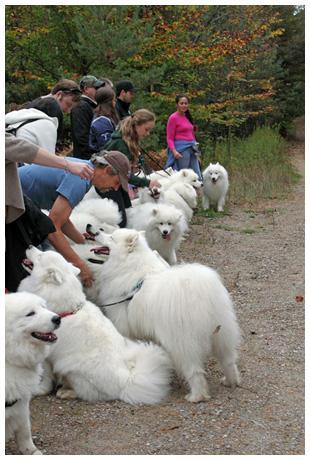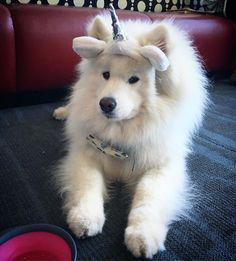The first image is the image on the left, the second image is the image on the right. For the images displayed, is the sentence "One image has a dog wearing more than just a collar or leash." factually correct? Answer yes or no. Yes. The first image is the image on the left, the second image is the image on the right. For the images shown, is this caption "In at least one image you can see at least one human wearing jeans feeding no less than 6 white dogs." true? Answer yes or no. Yes. 